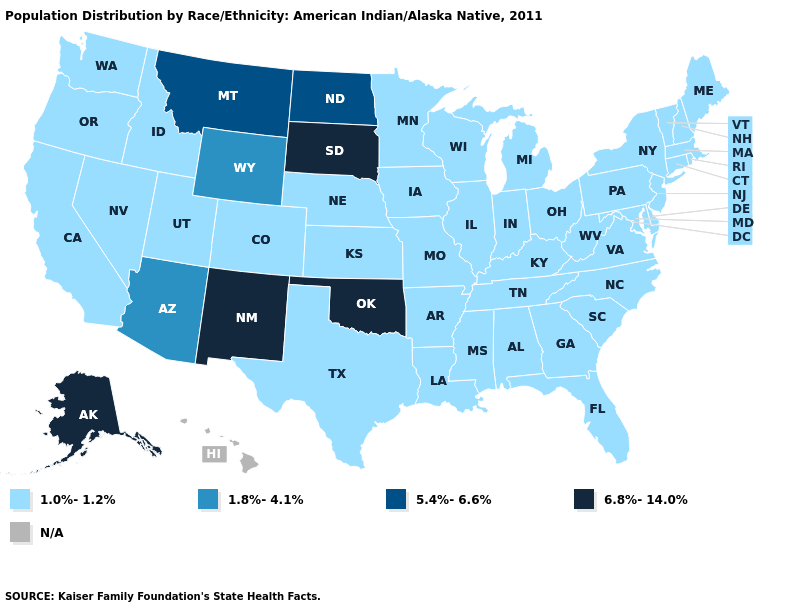Name the states that have a value in the range 5.4%-6.6%?
Short answer required. Montana, North Dakota. What is the value of North Dakota?
Be succinct. 5.4%-6.6%. What is the value of Michigan?
Write a very short answer. 1.0%-1.2%. What is the value of Maine?
Write a very short answer. 1.0%-1.2%. Name the states that have a value in the range 5.4%-6.6%?
Write a very short answer. Montana, North Dakota. What is the highest value in states that border New Mexico?
Give a very brief answer. 6.8%-14.0%. What is the value of New Mexico?
Give a very brief answer. 6.8%-14.0%. What is the highest value in the USA?
Keep it brief. 6.8%-14.0%. Name the states that have a value in the range 6.8%-14.0%?
Write a very short answer. Alaska, New Mexico, Oklahoma, South Dakota. Is the legend a continuous bar?
Answer briefly. No. Name the states that have a value in the range 6.8%-14.0%?
Answer briefly. Alaska, New Mexico, Oklahoma, South Dakota. What is the value of Missouri?
Write a very short answer. 1.0%-1.2%. Name the states that have a value in the range 1.8%-4.1%?
Keep it brief. Arizona, Wyoming. Name the states that have a value in the range 1.0%-1.2%?
Be succinct. Alabama, Arkansas, California, Colorado, Connecticut, Delaware, Florida, Georgia, Idaho, Illinois, Indiana, Iowa, Kansas, Kentucky, Louisiana, Maine, Maryland, Massachusetts, Michigan, Minnesota, Mississippi, Missouri, Nebraska, Nevada, New Hampshire, New Jersey, New York, North Carolina, Ohio, Oregon, Pennsylvania, Rhode Island, South Carolina, Tennessee, Texas, Utah, Vermont, Virginia, Washington, West Virginia, Wisconsin. 